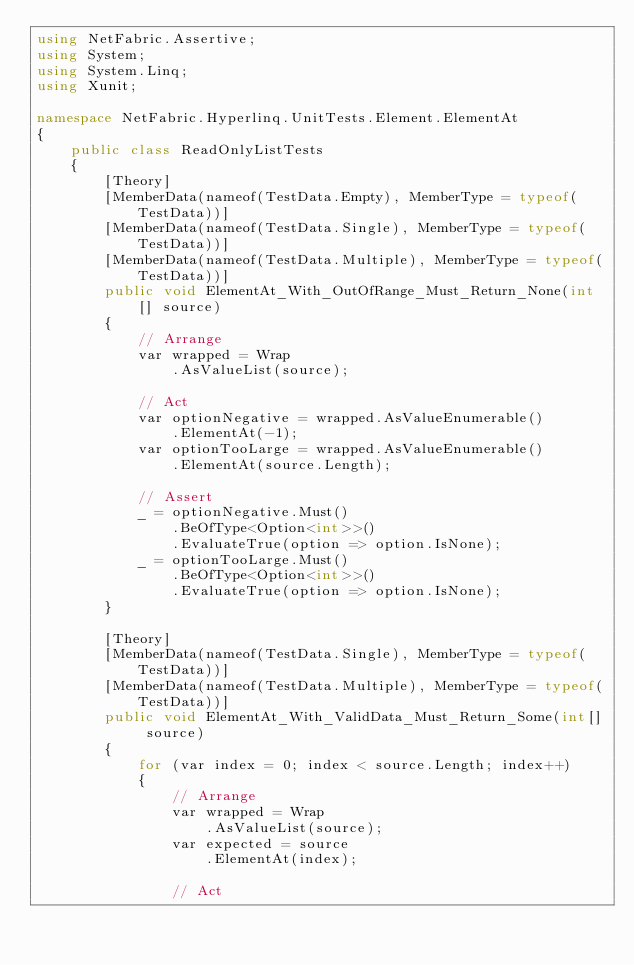Convert code to text. <code><loc_0><loc_0><loc_500><loc_500><_C#_>using NetFabric.Assertive;
using System;
using System.Linq;
using Xunit;

namespace NetFabric.Hyperlinq.UnitTests.Element.ElementAt
{
    public class ReadOnlyListTests
    {
        [Theory]
        [MemberData(nameof(TestData.Empty), MemberType = typeof(TestData))]
        [MemberData(nameof(TestData.Single), MemberType = typeof(TestData))]
        [MemberData(nameof(TestData.Multiple), MemberType = typeof(TestData))]
        public void ElementAt_With_OutOfRange_Must_Return_None(int[] source)
        {
            // Arrange
            var wrapped = Wrap
                .AsValueList(source);

            // Act
            var optionNegative = wrapped.AsValueEnumerable()
                .ElementAt(-1);
            var optionTooLarge = wrapped.AsValueEnumerable()
                .ElementAt(source.Length);

            // Assert
            _ = optionNegative.Must()
                .BeOfType<Option<int>>()
                .EvaluateTrue(option => option.IsNone);
            _ = optionTooLarge.Must()
                .BeOfType<Option<int>>()
                .EvaluateTrue(option => option.IsNone);
        }

        [Theory]
        [MemberData(nameof(TestData.Single), MemberType = typeof(TestData))]
        [MemberData(nameof(TestData.Multiple), MemberType = typeof(TestData))]
        public void ElementAt_With_ValidData_Must_Return_Some(int[] source)
        {
            for (var index = 0; index < source.Length; index++)
            {
                // Arrange
                var wrapped = Wrap
                    .AsValueList(source);
                var expected = source
                    .ElementAt(index);

                // Act</code> 